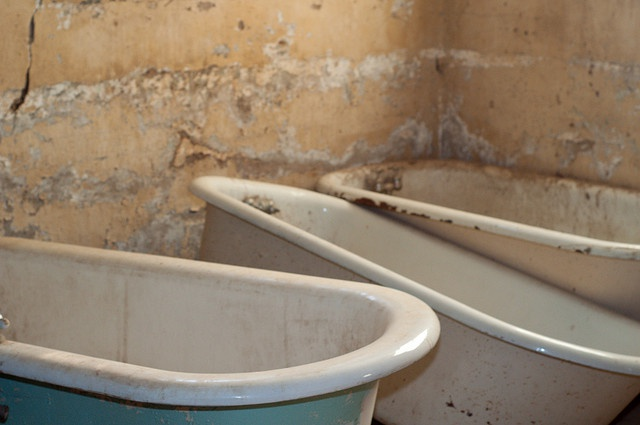Describe the objects in this image and their specific colors. I can see a sink in tan, darkgray, gray, and lightgray tones in this image. 